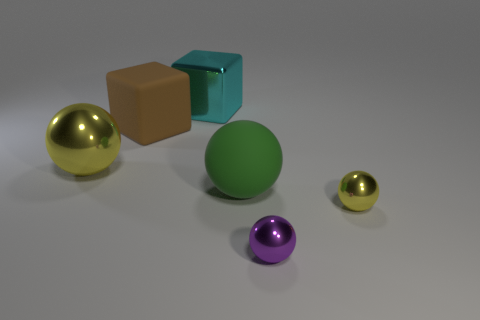Subtract all large yellow spheres. How many spheres are left? 3 Add 2 small purple metal balls. How many small purple metal balls are left? 3 Add 4 large balls. How many large balls exist? 6 Add 3 big metal cubes. How many objects exist? 9 Subtract all green balls. How many balls are left? 3 Subtract 1 cyan blocks. How many objects are left? 5 Subtract all cubes. How many objects are left? 4 Subtract 1 cubes. How many cubes are left? 1 Subtract all brown cubes. Subtract all yellow balls. How many cubes are left? 1 Subtract all blue balls. How many red blocks are left? 0 